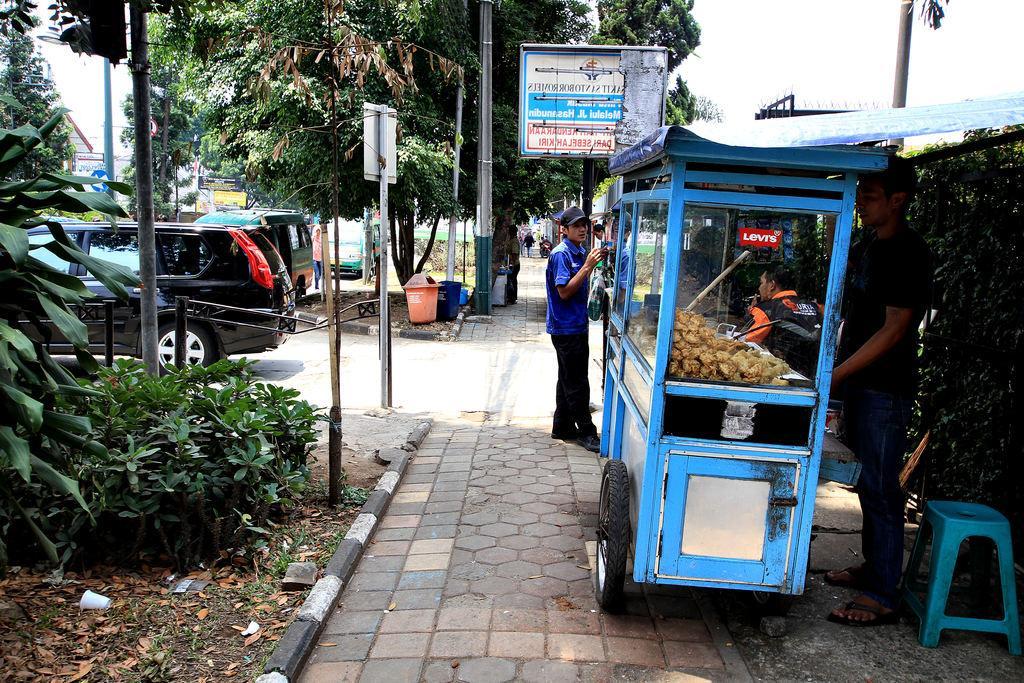How would you summarize this image in a sentence or two? In the picture I can see a street food vehicle on the right side and it is on the side of the road. I can see a man on the right side. I can see the cars and trees on the left side. I can see a traffic signal pole and cautious board poles on the side of the road. I can see the garbage boxes. 